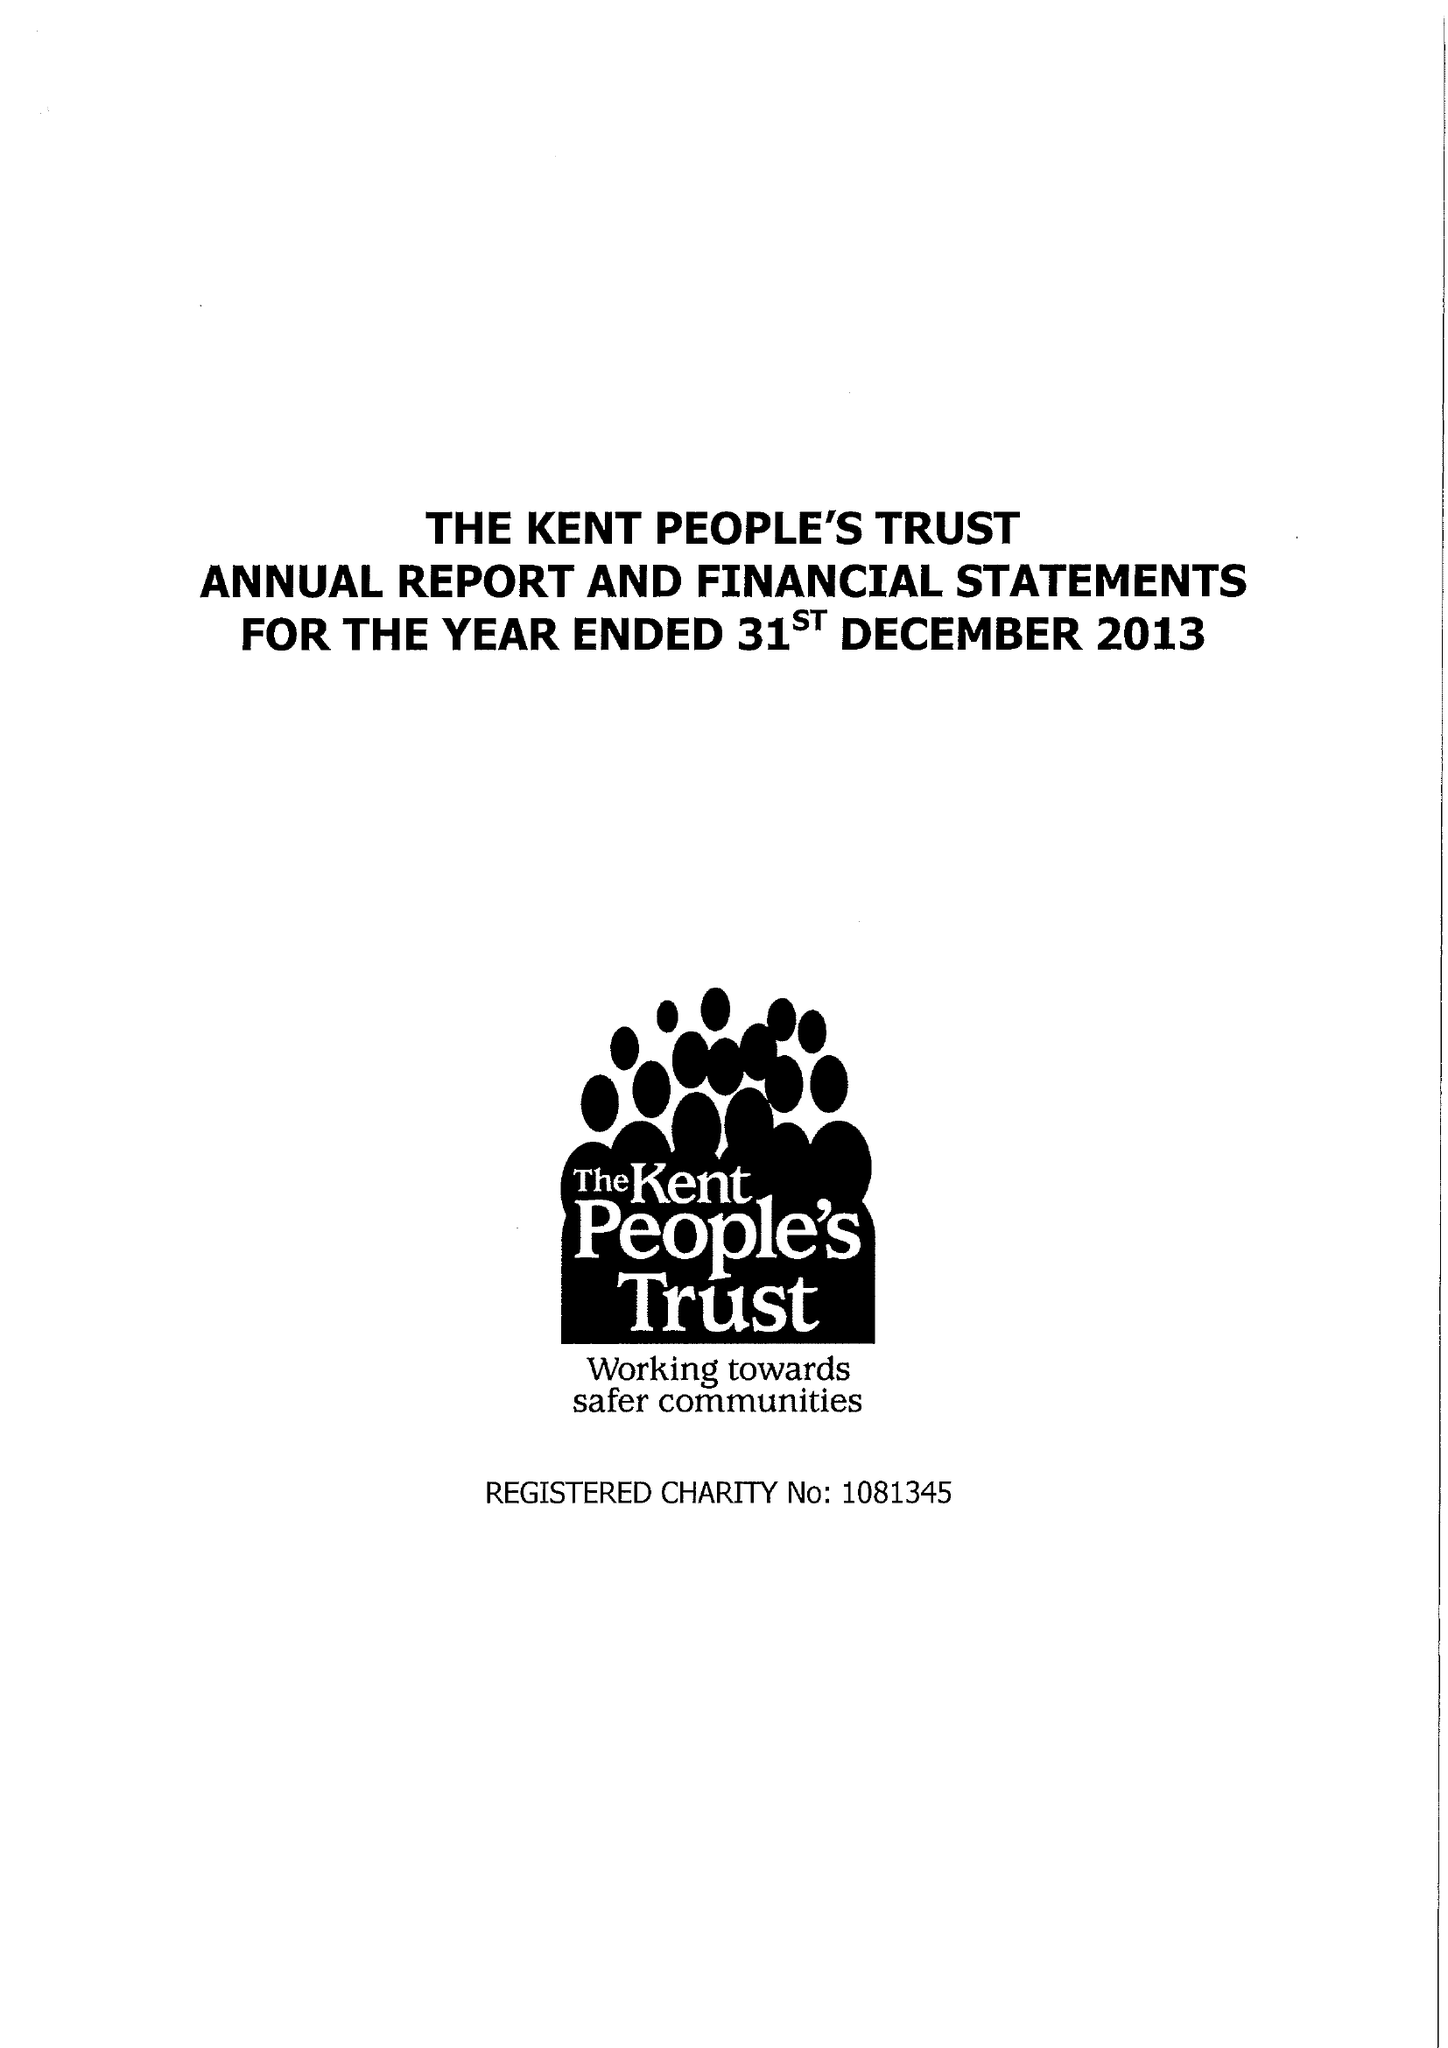What is the value for the income_annually_in_british_pounds?
Answer the question using a single word or phrase. 88956.00 